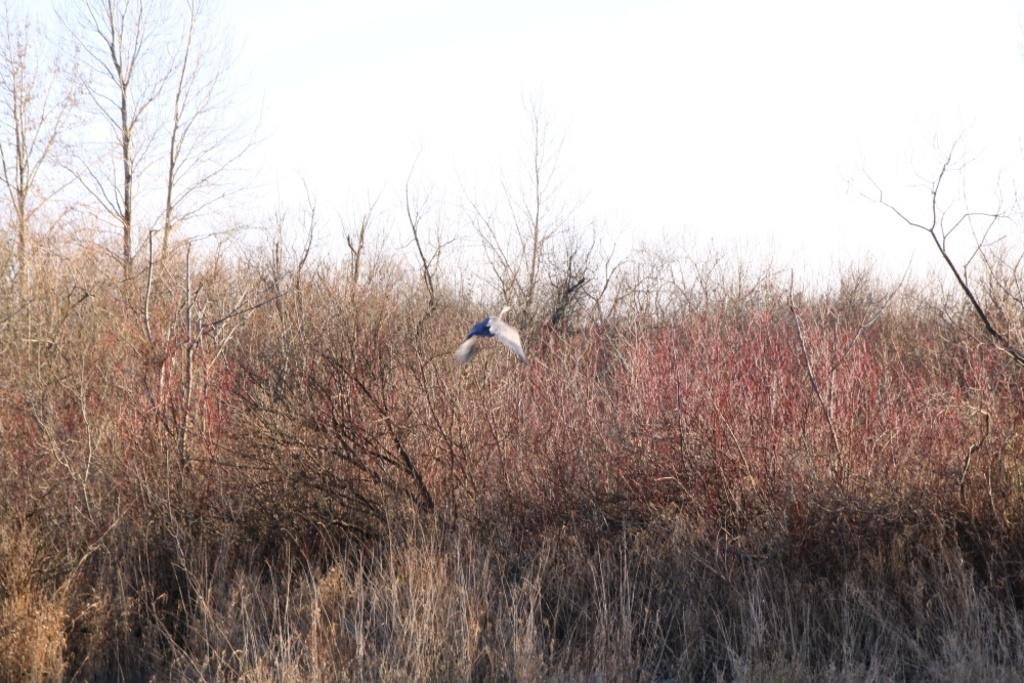What is the main subject in the center of the image? There is a bird in the center of the image. What is located at the bottom of the image? There is a lawn straw at the bottom of the image. What can be seen in the background of the image? There are trees and the sky visible in the background of the image. What type of jelly is being used to decorate the bird in the image? There is no jelly present in the image; it features a bird, lawn straw, trees, and sky. What kind of furniture can be seen in the image? There is no furniture present in the image. 